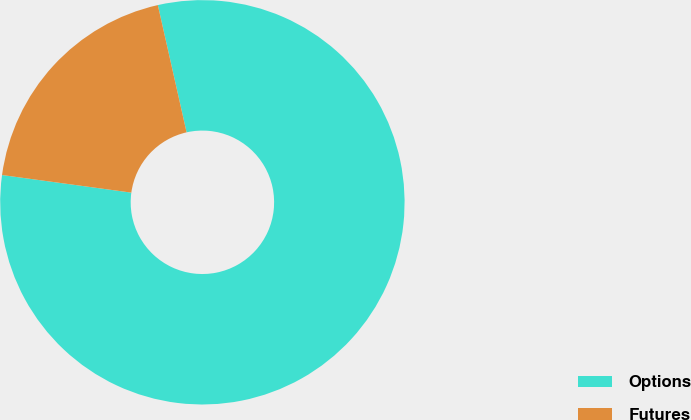Convert chart. <chart><loc_0><loc_0><loc_500><loc_500><pie_chart><fcel>Options<fcel>Futures<nl><fcel>80.69%<fcel>19.31%<nl></chart> 